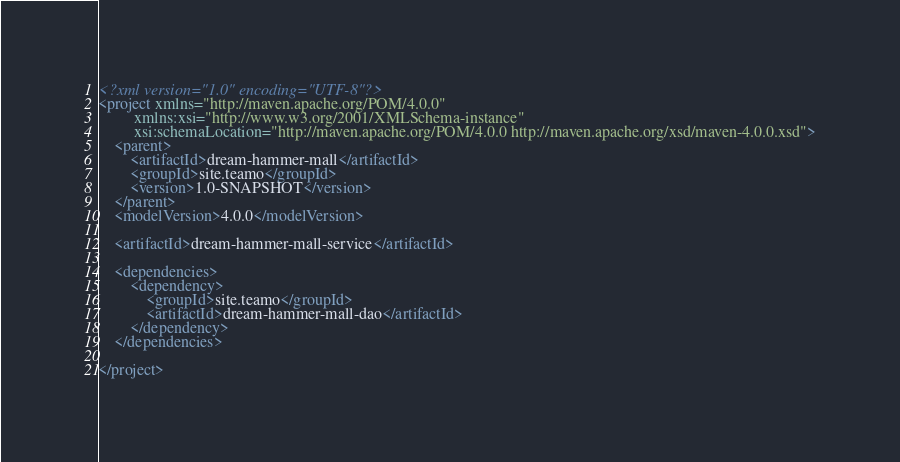<code> <loc_0><loc_0><loc_500><loc_500><_XML_><?xml version="1.0" encoding="UTF-8"?>
<project xmlns="http://maven.apache.org/POM/4.0.0"
         xmlns:xsi="http://www.w3.org/2001/XMLSchema-instance"
         xsi:schemaLocation="http://maven.apache.org/POM/4.0.0 http://maven.apache.org/xsd/maven-4.0.0.xsd">
    <parent>
        <artifactId>dream-hammer-mall</artifactId>
        <groupId>site.teamo</groupId>
        <version>1.0-SNAPSHOT</version>
    </parent>
    <modelVersion>4.0.0</modelVersion>

    <artifactId>dream-hammer-mall-service</artifactId>

    <dependencies>
        <dependency>
            <groupId>site.teamo</groupId>
            <artifactId>dream-hammer-mall-dao</artifactId>
        </dependency>
    </dependencies>

</project></code> 